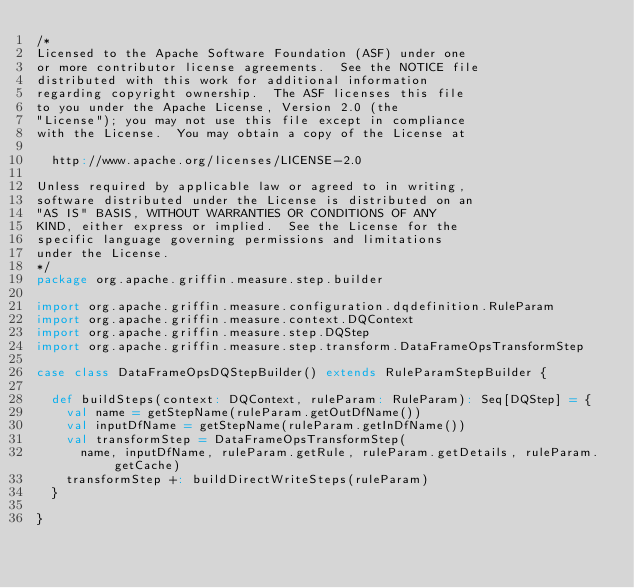Convert code to text. <code><loc_0><loc_0><loc_500><loc_500><_Scala_>/*
Licensed to the Apache Software Foundation (ASF) under one
or more contributor license agreements.  See the NOTICE file
distributed with this work for additional information
regarding copyright ownership.  The ASF licenses this file
to you under the Apache License, Version 2.0 (the
"License"); you may not use this file except in compliance
with the License.  You may obtain a copy of the License at

  http://www.apache.org/licenses/LICENSE-2.0

Unless required by applicable law or agreed to in writing,
software distributed under the License is distributed on an
"AS IS" BASIS, WITHOUT WARRANTIES OR CONDITIONS OF ANY
KIND, either express or implied.  See the License for the
specific language governing permissions and limitations
under the License.
*/
package org.apache.griffin.measure.step.builder

import org.apache.griffin.measure.configuration.dqdefinition.RuleParam
import org.apache.griffin.measure.context.DQContext
import org.apache.griffin.measure.step.DQStep
import org.apache.griffin.measure.step.transform.DataFrameOpsTransformStep

case class DataFrameOpsDQStepBuilder() extends RuleParamStepBuilder {

  def buildSteps(context: DQContext, ruleParam: RuleParam): Seq[DQStep] = {
    val name = getStepName(ruleParam.getOutDfName())
    val inputDfName = getStepName(ruleParam.getInDfName())
    val transformStep = DataFrameOpsTransformStep(
      name, inputDfName, ruleParam.getRule, ruleParam.getDetails, ruleParam.getCache)
    transformStep +: buildDirectWriteSteps(ruleParam)
  }

}
</code> 